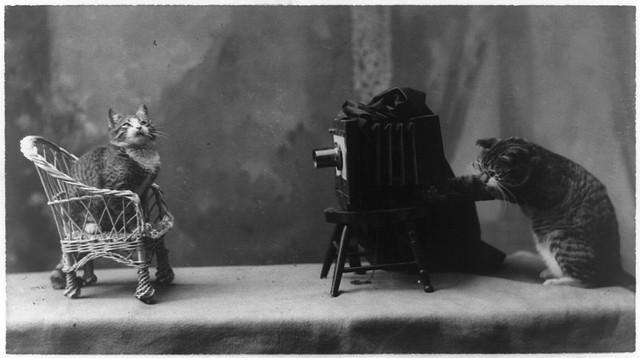How many props?
Give a very brief answer. 2. How many chairs are visible?
Give a very brief answer. 1. How many cats are in the picture?
Give a very brief answer. 2. How many people are looking down?
Give a very brief answer. 0. 